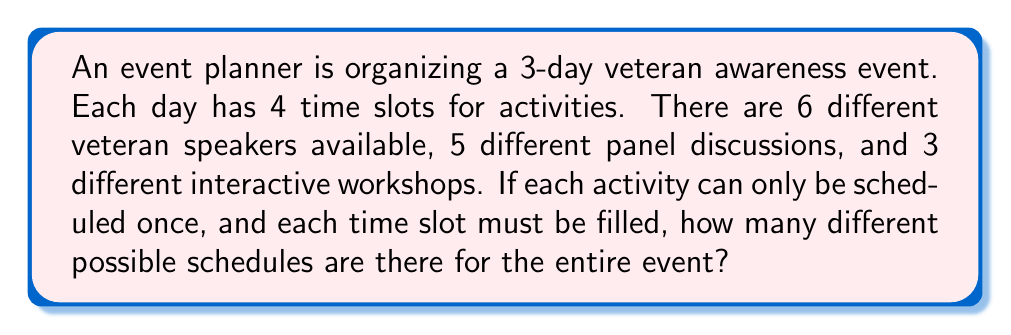Can you answer this question? Let's approach this step-by-step:

1) We have 3 days with 4 time slots each, so there are 12 total time slots to fill.

2) We need to choose 12 activities out of the total available activities:
   - 6 veteran speakers
   - 5 panel discussions
   - 3 interactive workshops
   Total: 6 + 5 + 3 = 14 activities

3) This is a permutation problem, as the order matters (different time slots).

4) We're selecting 12 activities out of 14, where each activity can only be used once. This is represented by the permutation formula:

   $$P(14,12) = \frac{14!}{(14-12)!} = \frac{14!}{2!}$$

5) Let's calculate this:
   $$\frac{14 * 13 * 12!}{2 * 1} = 14 * 13 * 11 * 10 * 9 * 8 * 7 * 6 * 5 * 4 * 3 * 2 * 1$$

6) This equals: 3,113,510,400

Therefore, there are 3,113,510,400 different possible schedules for the entire event.
Answer: 3,113,510,400 